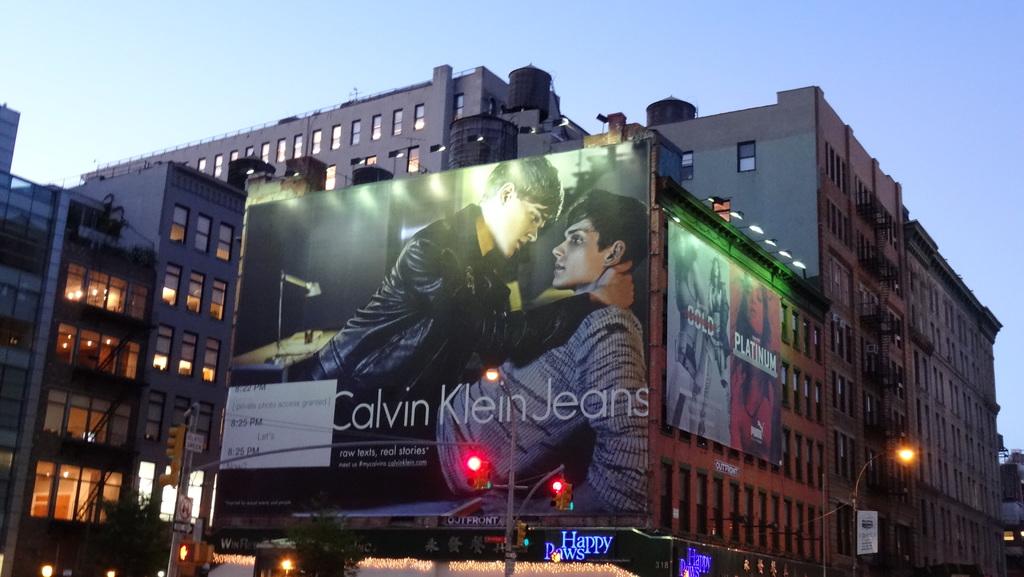What company is advertising on this billboard?
Ensure brevity in your answer.  Calvin klein. What kind of product is calvin klein advertising?
Provide a succinct answer. Jeans. 